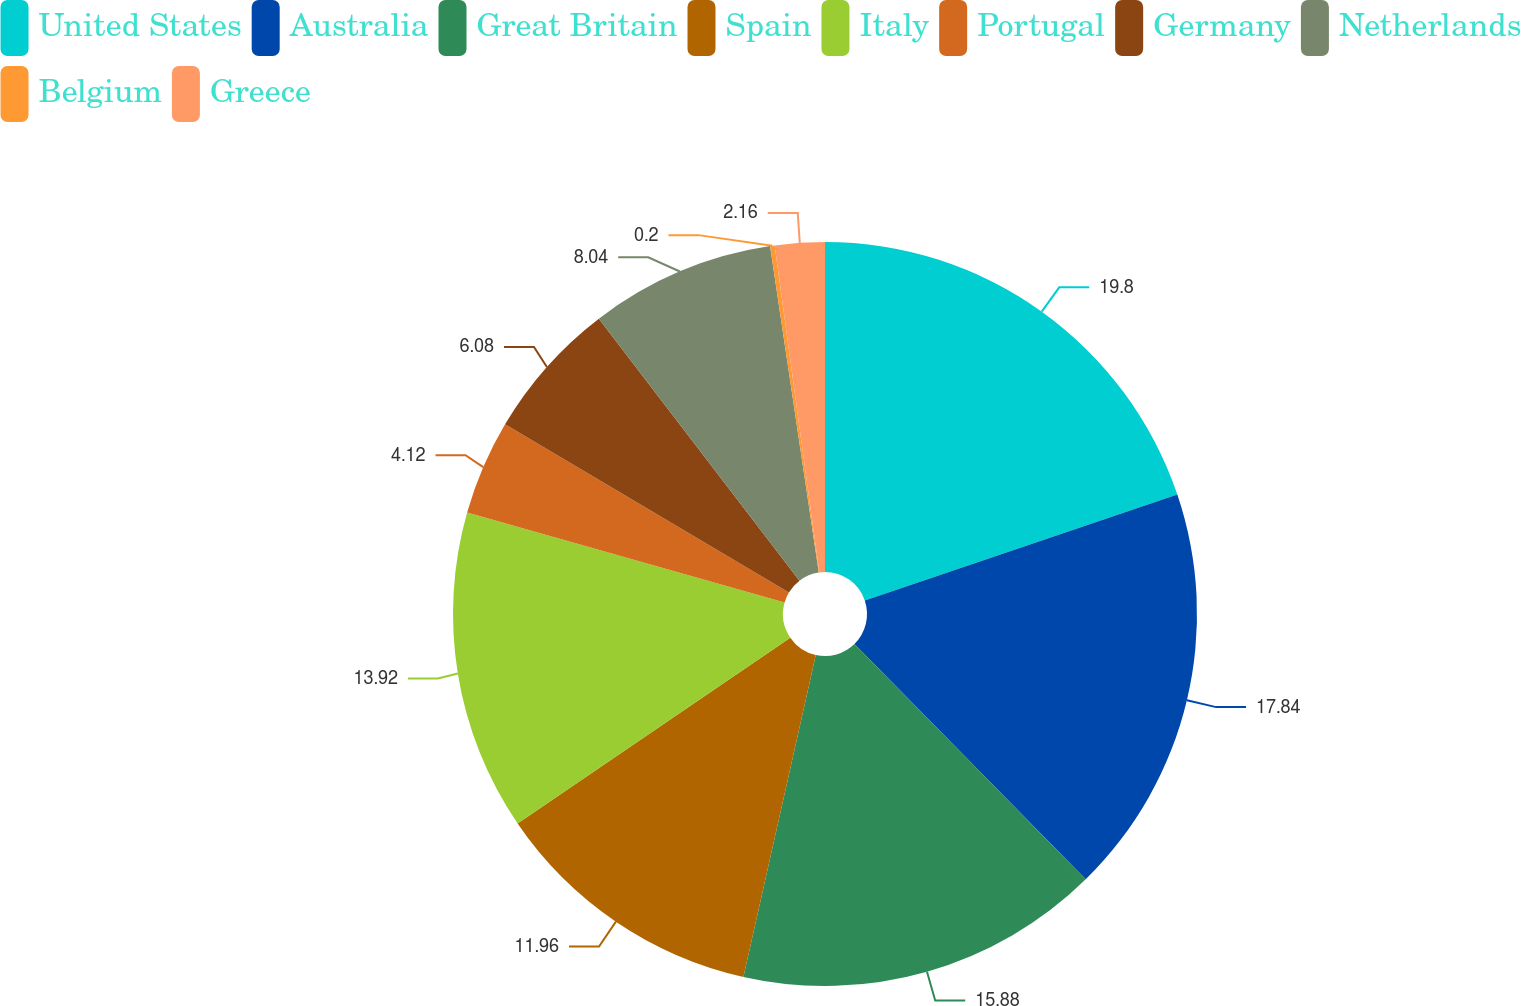<chart> <loc_0><loc_0><loc_500><loc_500><pie_chart><fcel>United States<fcel>Australia<fcel>Great Britain<fcel>Spain<fcel>Italy<fcel>Portugal<fcel>Germany<fcel>Netherlands<fcel>Belgium<fcel>Greece<nl><fcel>19.8%<fcel>17.84%<fcel>15.88%<fcel>11.96%<fcel>13.92%<fcel>4.12%<fcel>6.08%<fcel>8.04%<fcel>0.2%<fcel>2.16%<nl></chart> 